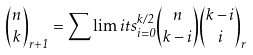Convert formula to latex. <formula><loc_0><loc_0><loc_500><loc_500>\binom { n } { k } _ { r + 1 } = \sum \lim i t s _ { i = 0 } ^ { k / 2 } \binom { n } { k - i } \binom { k - i } { i } _ { r }</formula> 